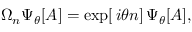Convert formula to latex. <formula><loc_0><loc_0><loc_500><loc_500>\Omega _ { n } \Psi _ { \theta } [ A ] = \exp [ \, i \theta n ] \, \Psi _ { \theta } [ A ] ,</formula> 